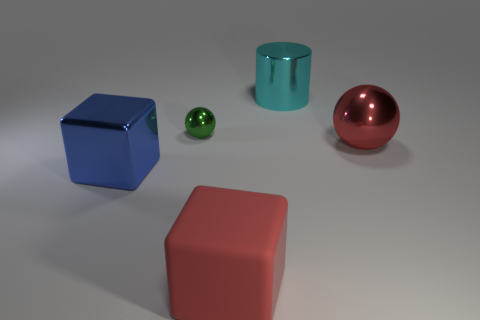Add 2 balls. How many objects exist? 7 Subtract all blocks. How many objects are left? 3 Subtract all red rubber objects. Subtract all big cylinders. How many objects are left? 3 Add 3 cyan cylinders. How many cyan cylinders are left? 4 Add 3 big objects. How many big objects exist? 7 Subtract 0 yellow blocks. How many objects are left? 5 